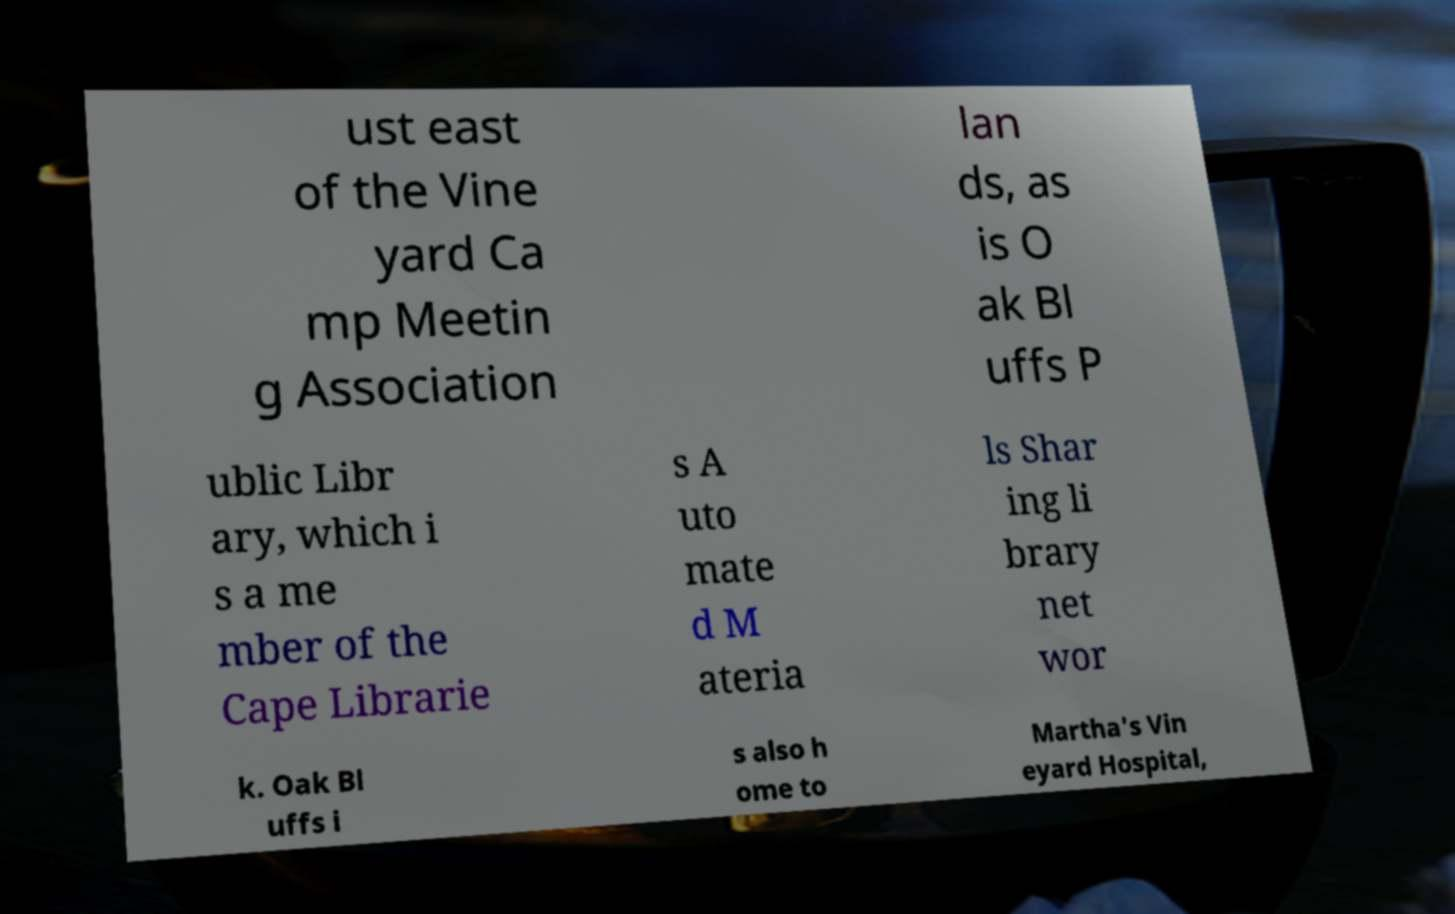Can you accurately transcribe the text from the provided image for me? ust east of the Vine yard Ca mp Meetin g Association lan ds, as is O ak Bl uffs P ublic Libr ary, which i s a me mber of the Cape Librarie s A uto mate d M ateria ls Shar ing li brary net wor k. Oak Bl uffs i s also h ome to Martha's Vin eyard Hospital, 